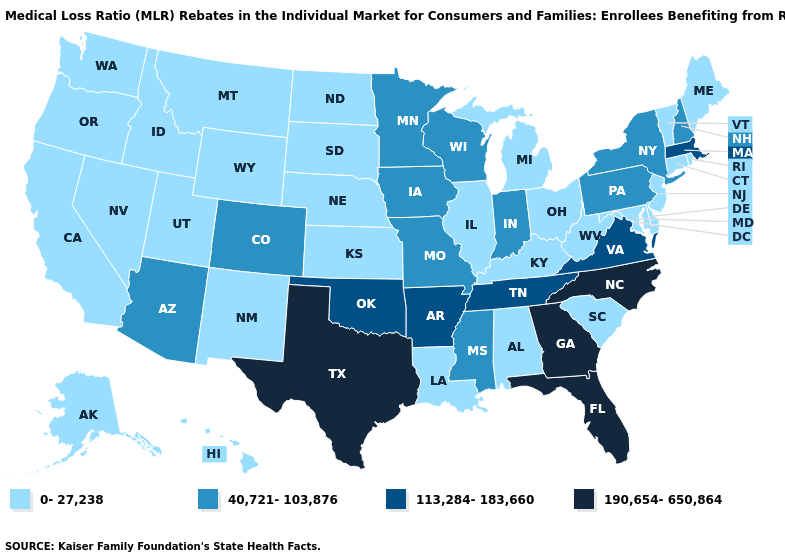Name the states that have a value in the range 190,654-650,864?
Quick response, please. Florida, Georgia, North Carolina, Texas. Name the states that have a value in the range 40,721-103,876?
Write a very short answer. Arizona, Colorado, Indiana, Iowa, Minnesota, Mississippi, Missouri, New Hampshire, New York, Pennsylvania, Wisconsin. Does the first symbol in the legend represent the smallest category?
Quick response, please. Yes. What is the value of Connecticut?
Be succinct. 0-27,238. What is the highest value in the MidWest ?
Quick response, please. 40,721-103,876. What is the value of North Carolina?
Concise answer only. 190,654-650,864. What is the highest value in the USA?
Keep it brief. 190,654-650,864. Does the first symbol in the legend represent the smallest category?
Short answer required. Yes. What is the lowest value in the USA?
Keep it brief. 0-27,238. Name the states that have a value in the range 113,284-183,660?
Concise answer only. Arkansas, Massachusetts, Oklahoma, Tennessee, Virginia. Among the states that border Michigan , does Indiana have the highest value?
Answer briefly. Yes. Does Kansas have the highest value in the USA?
Quick response, please. No. Does New Hampshire have the lowest value in the USA?
Be succinct. No. What is the highest value in the MidWest ?
Be succinct. 40,721-103,876. 